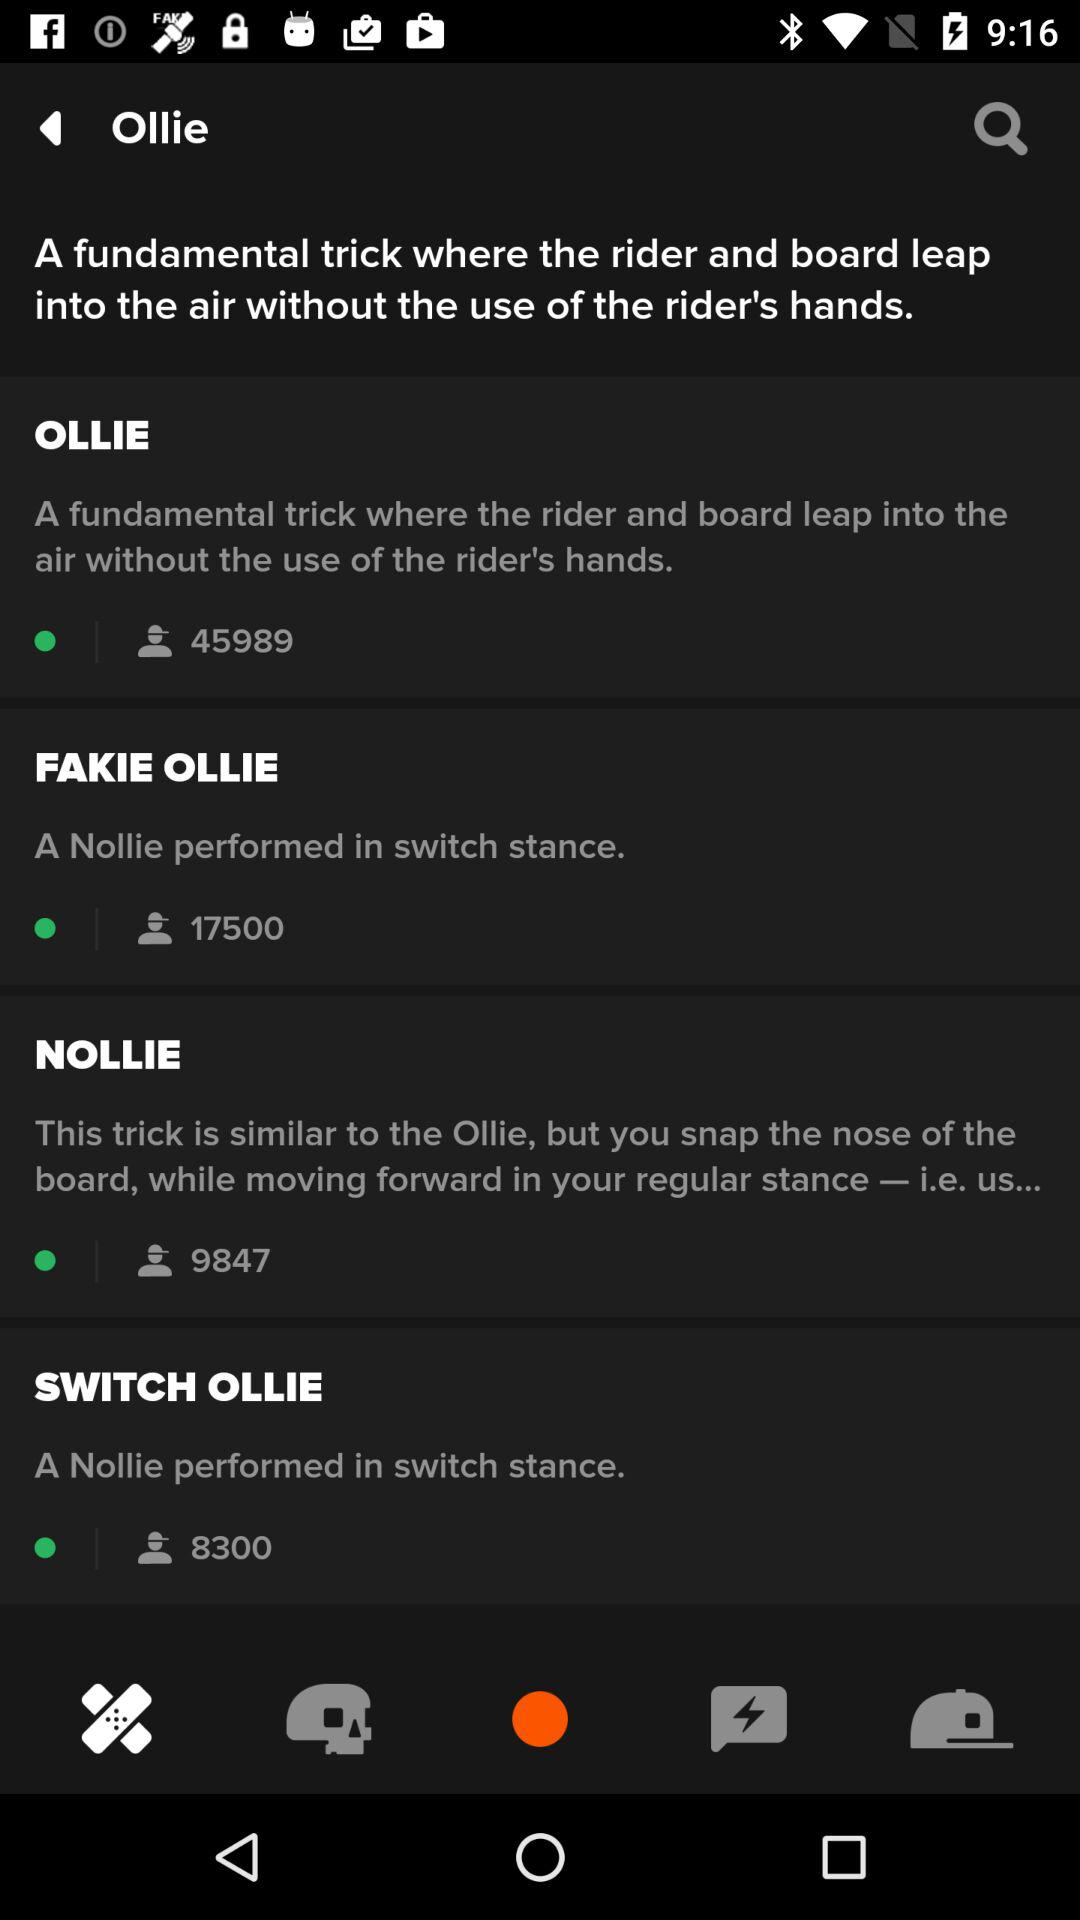How many more views does the ollie have than the fakie ollie?
Answer the question using a single word or phrase. 28489 